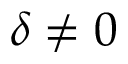<formula> <loc_0><loc_0><loc_500><loc_500>\delta \neq 0</formula> 